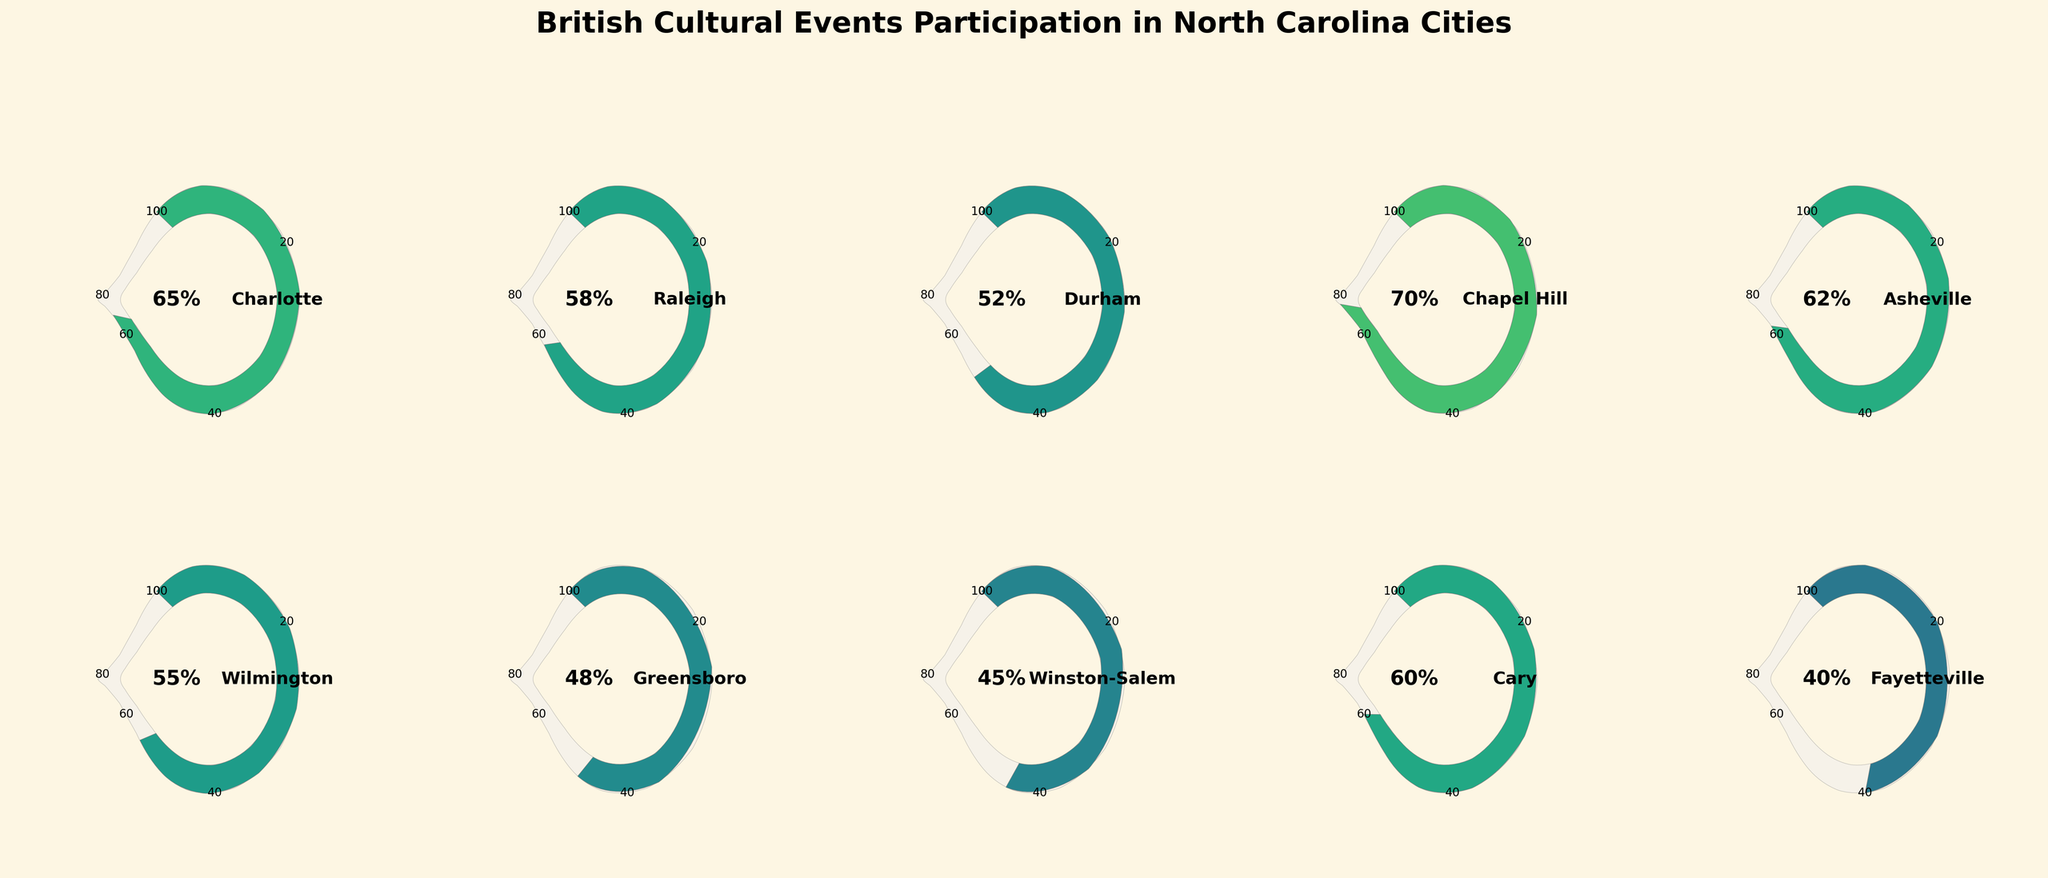What does the figure's title indicate? The title of the figure specifies the content being displayed, which is the level of participation in British cultural events in different cities across North Carolina.
Answer: British Cultural Events Participation in North Carolina Cities Which city has the highest participation rate in British cultural events? By looking at the gauge charts for each city, the one with the highest value displayed on the gauge is Chapel Hill at 70%.
Answer: Chapel Hill What is the participation rate of British cultural events in Raleigh? Observing the gauge chart for Raleigh, the value indicated is 58%.
Answer: 58% How many cities have a participation rate of 60% or higher? By counting the gauges that show 60% or more, the cities are Charlotte, Chapel Hill, Asheville, and Cary.
Answer: 4 Which city has the lowest participation rate in British cultural events? By identifying the gauge with the smallest value displayed, Fayetteville has the lowest participation rate at 40%.
Answer: Fayetteville What is the average participation rate in British cultural events across all listed cities? Summing up the participation rates (65 + 58 + 52 + 70 + 62 + 55 + 48 + 45 + 60 + 40) gives 555, dividing by the number of cities (10) gives an average of 55.5%.
Answer: 55.5% How does the participation rate in Durham compare to that in Wilmington? The participation rate in Durham is 52%, while in Wilmington, it is 55%, making Wilmington slightly higher.
Answer: Wilmington is higher What is the participation range of British cultural events across the cities? The range is calculated by subtracting the lowest value (Fayetteville 40%) from the highest value (Chapel Hill 70%), resulting in a range of 30%.
Answer: 30% If you are planning to move to a city with at least 60% participation in British cultural events, which options do you have? From the data, the cities with 60% or higher participation are Charlotte, Chapel Hill, Asheville, and Cary.
Answer: Charlotte, Chapel Hill, Asheville, Cary 